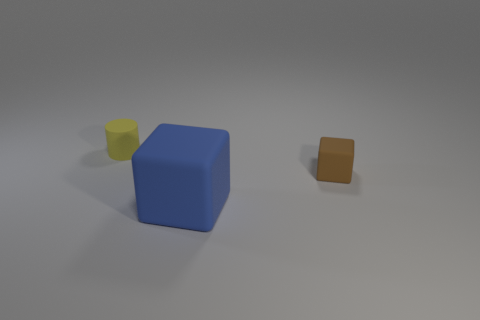What color is the other big rubber thing that is the same shape as the brown object?
Provide a succinct answer. Blue. What is the shape of the brown thing?
Provide a short and direct response. Cube. What number of objects are either tiny rubber cylinders or small yellow rubber cubes?
Your answer should be very brief. 1. How many other things are the same shape as the yellow thing?
Make the answer very short. 0. Are there any tiny cyan matte things?
Give a very brief answer. No. How many things are either gray spheres or matte things right of the big blue rubber cube?
Your response must be concise. 1. There is a object that is behind the brown rubber block; is it the same size as the blue cube?
Ensure brevity in your answer.  No. How many other things are there of the same size as the blue cube?
Ensure brevity in your answer.  0. The tiny matte cylinder is what color?
Give a very brief answer. Yellow. What material is the small thing right of the large rubber block?
Ensure brevity in your answer.  Rubber. 